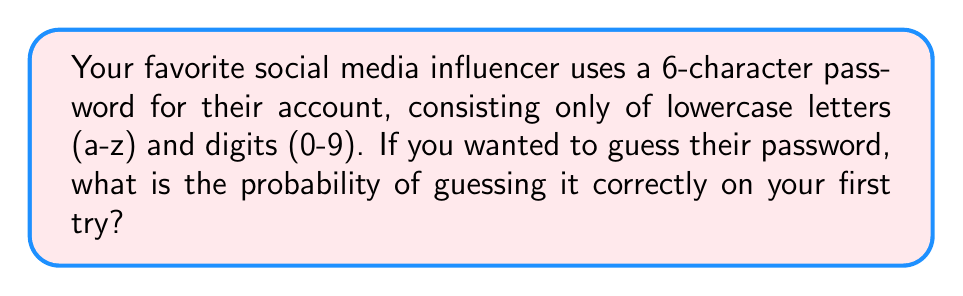Provide a solution to this math problem. Let's approach this step-by-step:

1) First, we need to determine the total number of possible characters:
   - 26 lowercase letters (a-z)
   - 10 digits (0-9)
   Total: 26 + 10 = 36 possible characters

2) Now, for each of the 6 positions in the password, we have 36 choices.

3) Using the multiplication principle, the total number of possible passwords is:
   $$ 36^6 = 2,176,782,336 $$

4) The probability of guessing the correct password on the first try is:
   $$ P(\text{correct guess}) = \frac{\text{number of favorable outcomes}}{\text{total number of possible outcomes}} $$

5) There is only one correct password out of all possibilities, so:
   $$ P(\text{correct guess}) = \frac{1}{36^6} = \frac{1}{2,176,782,336} $$

6) This can be simplified to:
   $$ P(\text{correct guess}) \approx 4.59 \times 10^{-10} $$
Answer: $\frac{1}{36^6}$ or approximately $4.59 \times 10^{-10}$ 